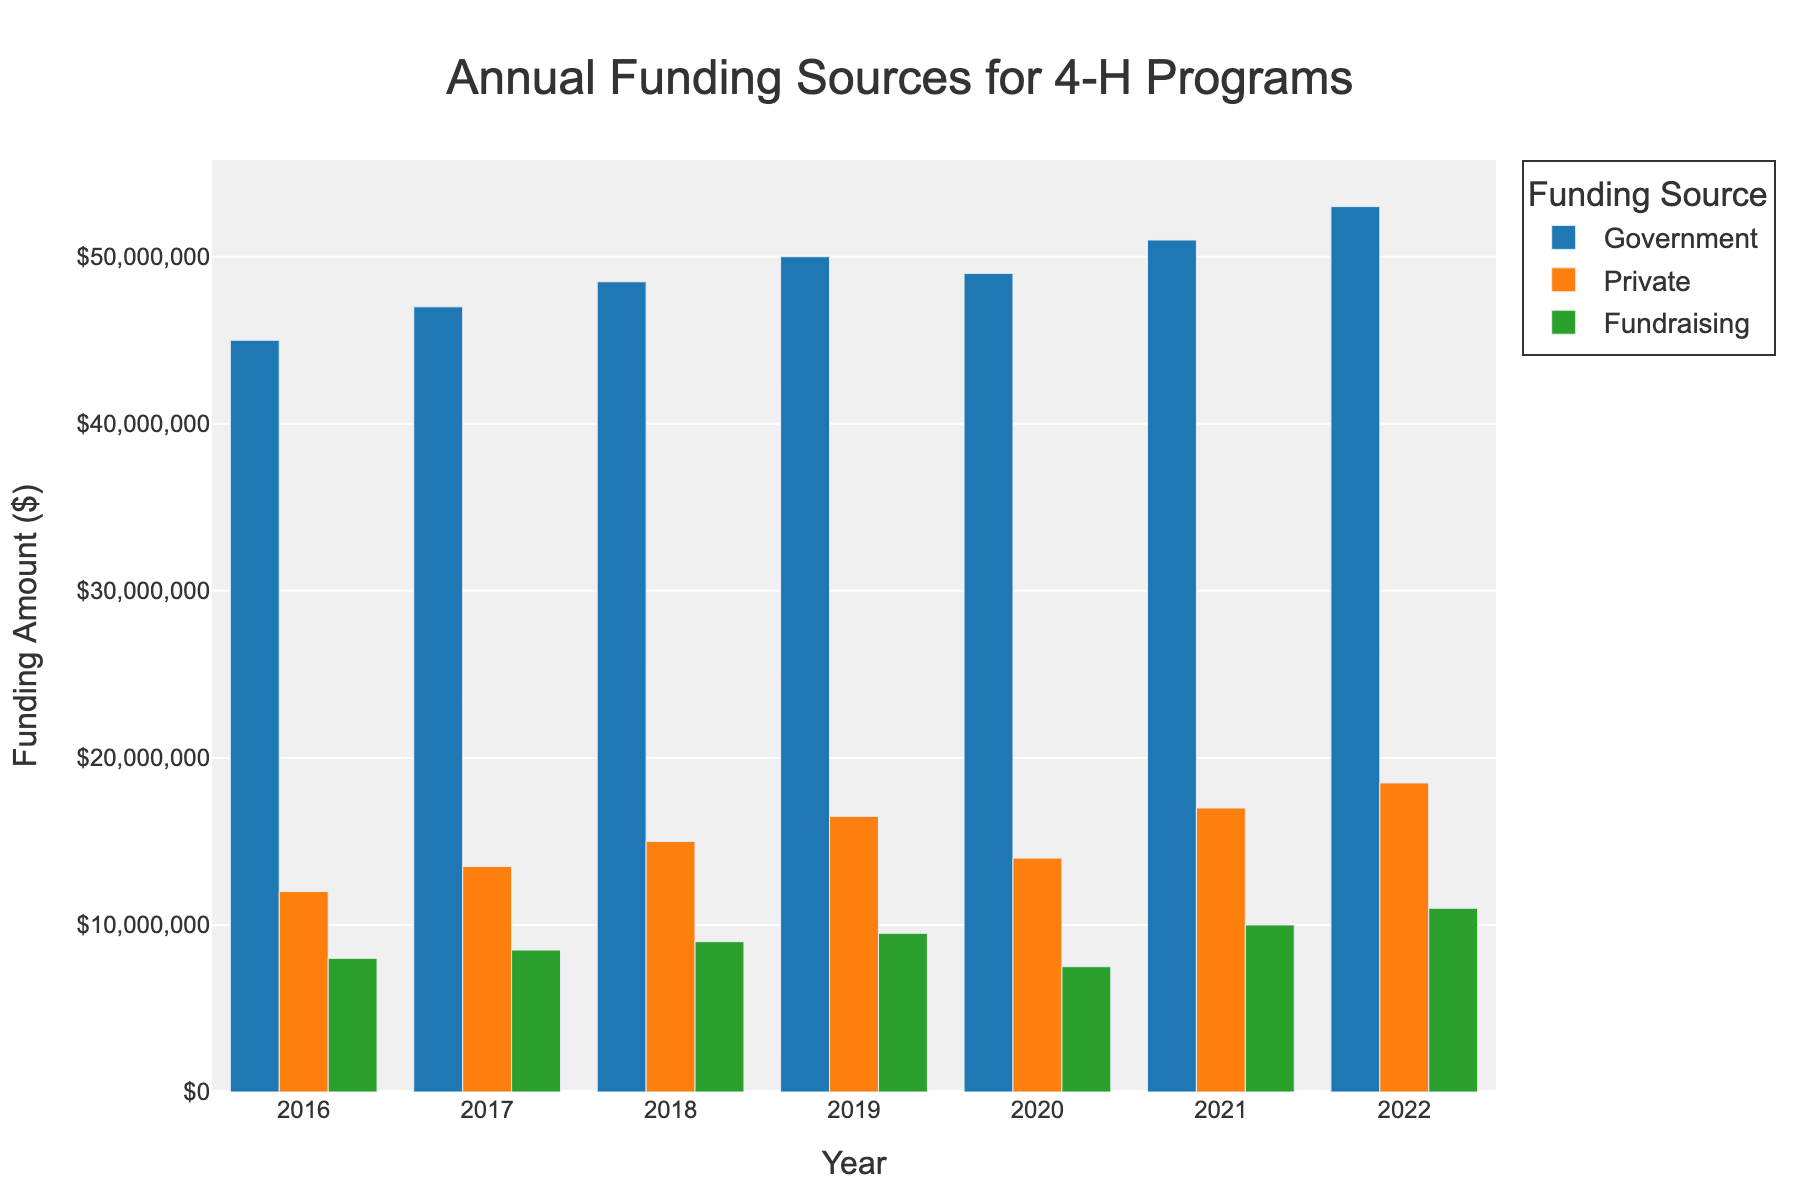what is the total funding amount in 2018? Sum the funding amounts from Government, Private, and Fundraising for 2018: $48,500,000 + $15,000,000 + $9,000,000 = $72,500,000
Answer: $72,500,000 How much more was raised through government funding compared to private funding in 2019? Subtract the private funding amount from the government funding amount in 2019: $50,000,000 - $16,500,000 = $33,500,000
Answer: $33,500,000 What was the average annual government funding from 2016 to 2022? Sum the government funding amounts from 2016 to 2022 and divide by 7: ($45,000,000 + $47,000,000 + $48,500,000 + $50,000,000 + $49,000,000 + $51,000,000 + $53,000,000) / 7 = $49,357,142.86
Answer: $49,357,142.86 Which year had the highest total private funding? Identify the year with the highest private funding amount: 2022, with $18,500,000
Answer: 2022 In which year was the gap between government funding and fundraising the smallest? Calculate the difference between government funding and fundraising for each year, and identify the year with the smallest difference: 2017 ($47,000,000 - $8,500,000 = $38,500,000)
Answer: 2017 What is the trend in government funding from 2016 to 2022? Observe the bars for government funding from 2016 to 2022 and note that the funding generally increased, with a slight dip in 2020.
Answer: Increasing trend Which funding source had the least growth from 2016 to 2022? Compare the growth of each funding source from 2016 to 2022: Government ($53,000,000 - $45,000,000 = $8,000,000), Private ($18,500,000 - $12,000,000 = $6,500,000), Fundraising ($11,000,000 - $8,000,000 = $3,000,000). Fundraising has the least growth.
Answer: Fundraising What was the total fundraising amount over the entire period? Sum the fundraising amounts from 2016 to 2022: $8,000,000 + $8,500,000 + $9,000,000 + $9,500,000 + $7,500,000 + $10,000,000 + $11,000,000 = $63,500,000
Answer: $63,500,000 Which funding source had the highest contribution in 2021? Check the funding amounts for each source in 2021 and identify the highest one: Government with $51,000,000
Answer: Government By how much did private funding increase from 2016 to 2022? Subtract the private funding amount in 2016 from that in 2022: $18,500,000 - $12,000,000 = $6,500,000
Answer: $6,500,000 